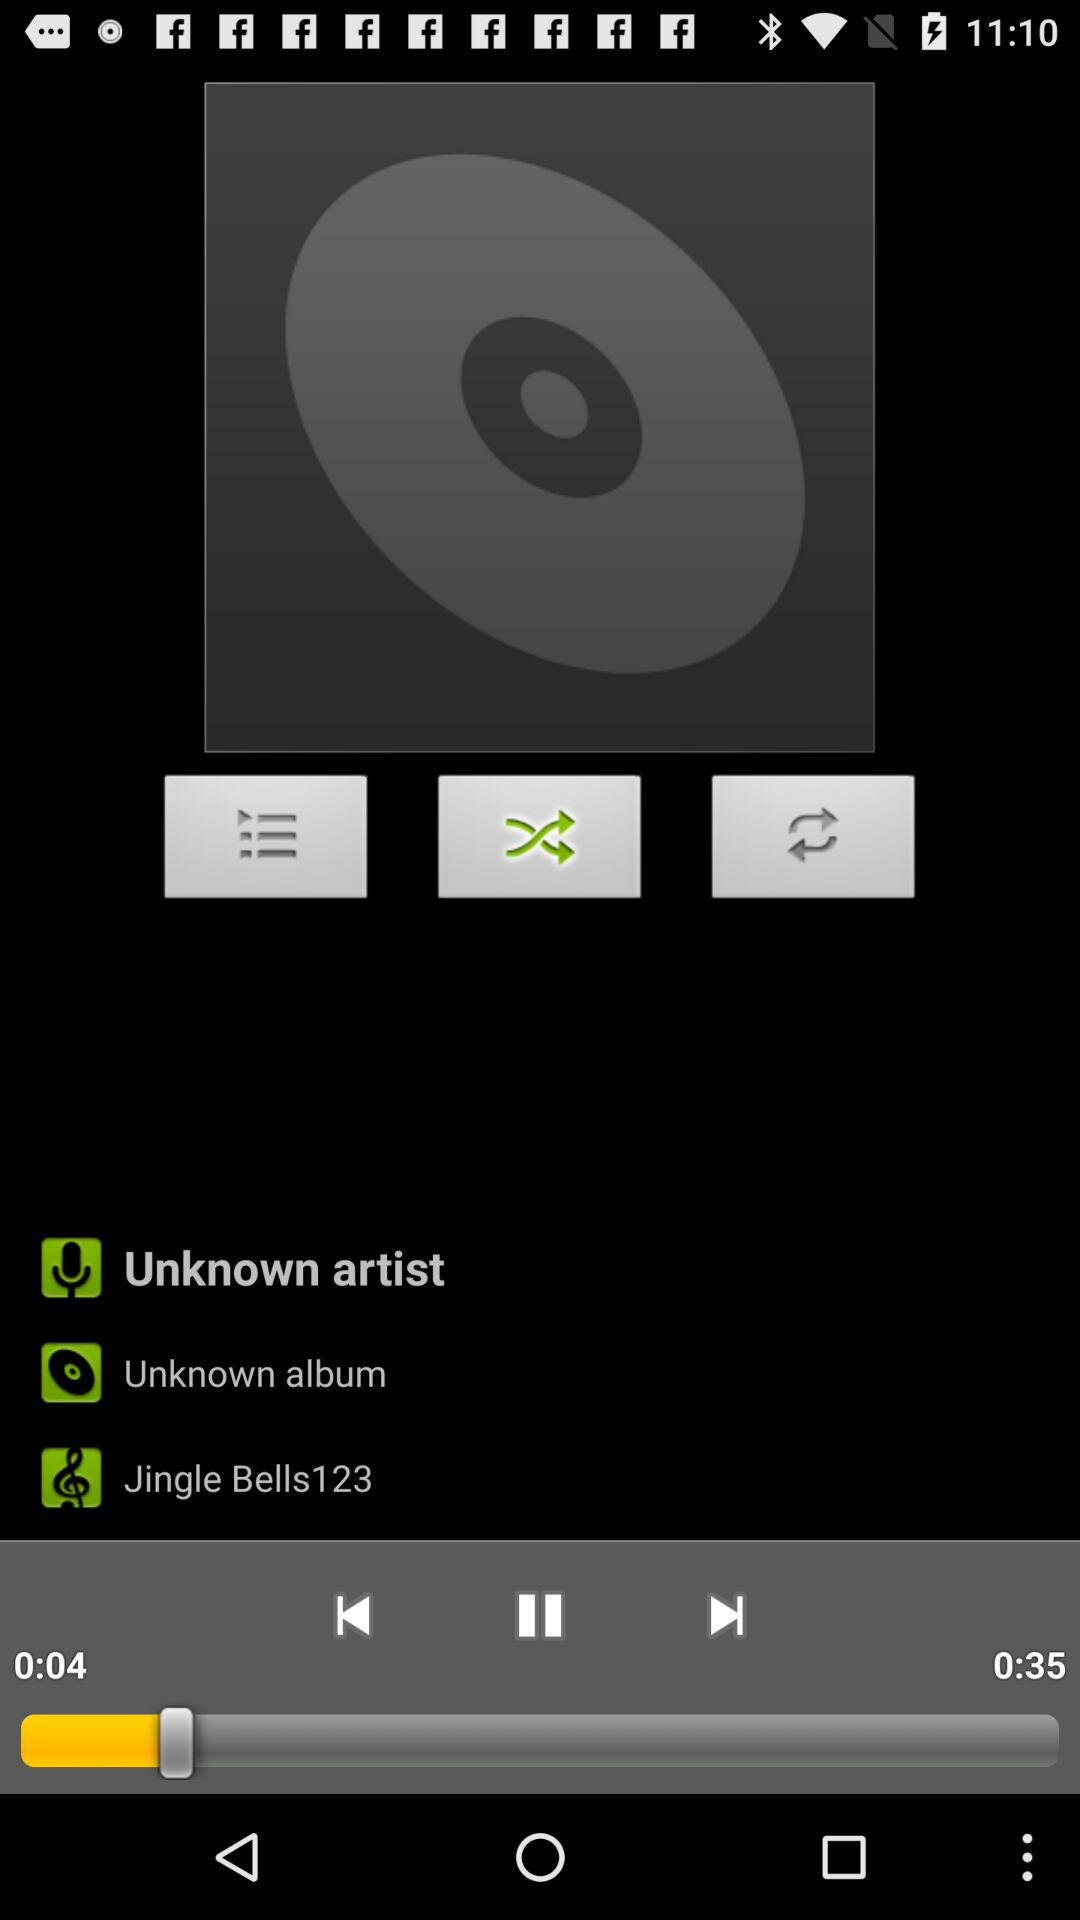For how long has the song been played? The song has been played for 4 seconds. 